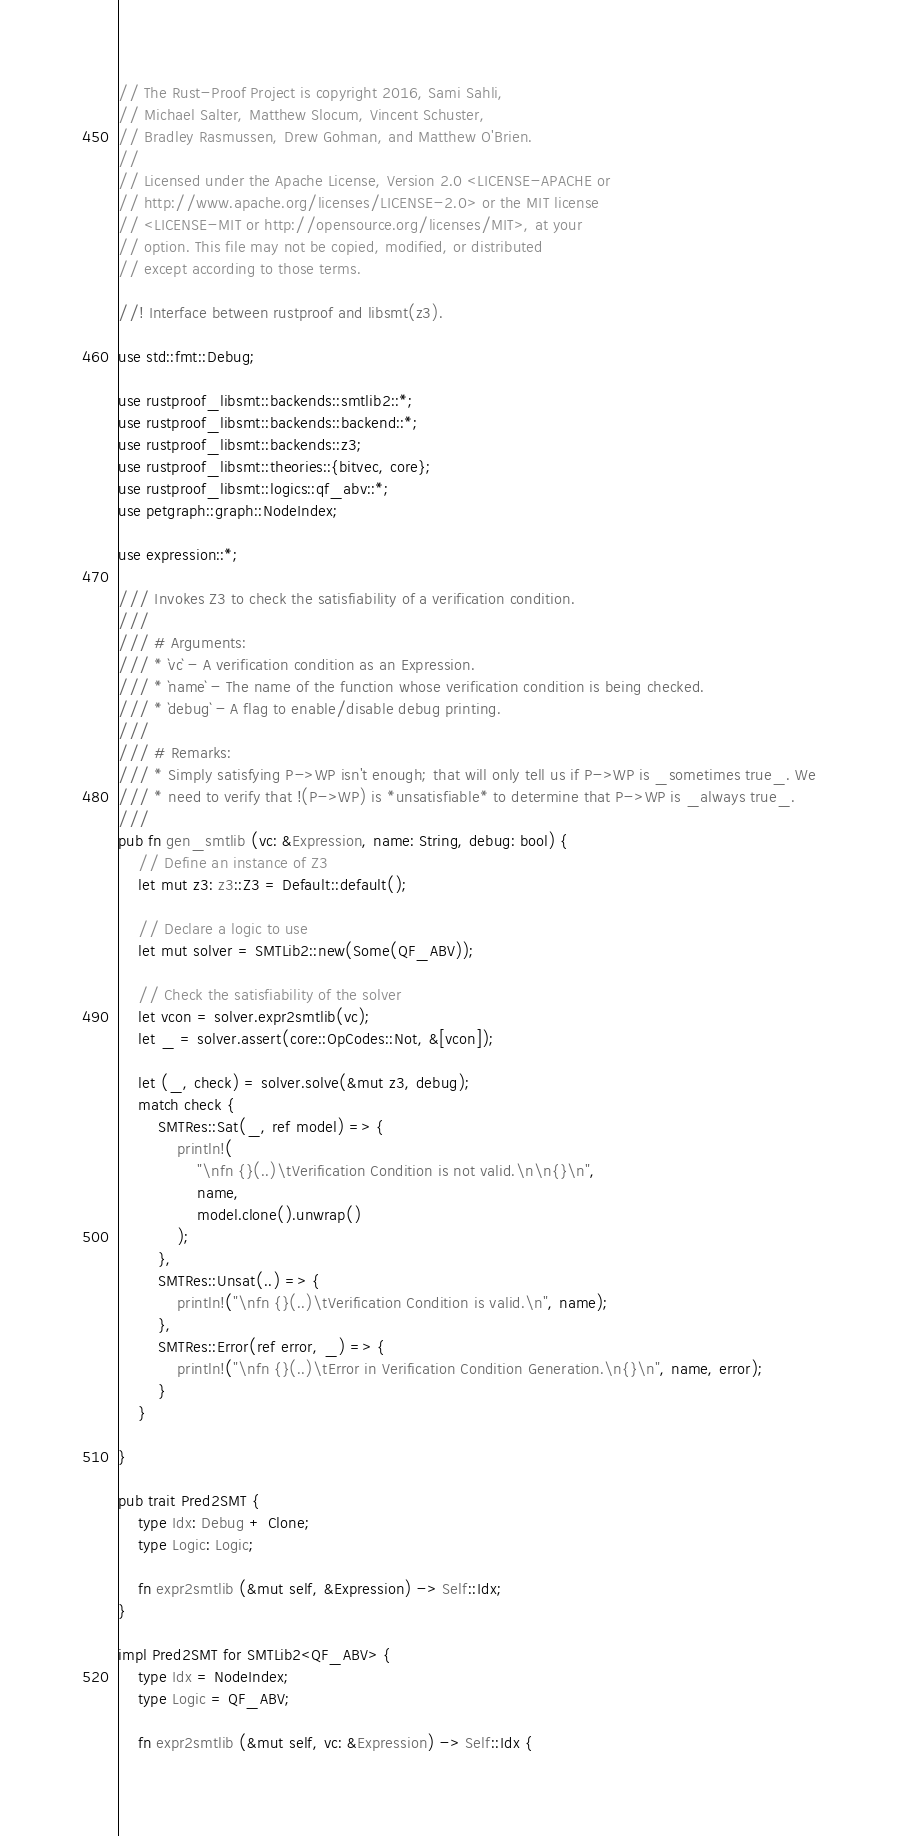Convert code to text. <code><loc_0><loc_0><loc_500><loc_500><_Rust_>// The Rust-Proof Project is copyright 2016, Sami Sahli,
// Michael Salter, Matthew Slocum, Vincent Schuster,
// Bradley Rasmussen, Drew Gohman, and Matthew O'Brien.
//
// Licensed under the Apache License, Version 2.0 <LICENSE-APACHE or
// http://www.apache.org/licenses/LICENSE-2.0> or the MIT license
// <LICENSE-MIT or http://opensource.org/licenses/MIT>, at your
// option. This file may not be copied, modified, or distributed
// except according to those terms.

//! Interface between rustproof and libsmt(z3).

use std::fmt::Debug;

use rustproof_libsmt::backends::smtlib2::*;
use rustproof_libsmt::backends::backend::*;
use rustproof_libsmt::backends::z3;
use rustproof_libsmt::theories::{bitvec, core};
use rustproof_libsmt::logics::qf_abv::*;
use petgraph::graph::NodeIndex;

use expression::*;

/// Invokes Z3 to check the satisfiability of a verification condition.
///
/// # Arguments:
/// * `vc` - A verification condition as an Expression.
/// * `name` - The name of the function whose verification condition is being checked.
/// * `debug` - A flag to enable/disable debug printing.
///
/// # Remarks:
/// * Simply satisfying P->WP isn't enough; that will only tell us if P->WP is _sometimes true_. We
/// * need to verify that !(P->WP) is *unsatisfiable* to determine that P->WP is _always true_.
///
pub fn gen_smtlib (vc: &Expression, name: String, debug: bool) {
    // Define an instance of Z3
    let mut z3: z3::Z3 = Default::default();

    // Declare a logic to use
    let mut solver = SMTLib2::new(Some(QF_ABV));

    // Check the satisfiability of the solver
    let vcon = solver.expr2smtlib(vc);
    let _ = solver.assert(core::OpCodes::Not, &[vcon]);

    let (_, check) = solver.solve(&mut z3, debug);
    match check {
        SMTRes::Sat(_, ref model) => {
            println!(
                "\nfn {}(..)\tVerification Condition is not valid.\n\n{}\n",
                name,
                model.clone().unwrap()
            );
        },
        SMTRes::Unsat(..) => {
            println!("\nfn {}(..)\tVerification Condition is valid.\n", name);
        },
        SMTRes::Error(ref error, _) => {
            println!("\nfn {}(..)\tError in Verification Condition Generation.\n{}\n", name, error);
        }
    }

}

pub trait Pred2SMT {
    type Idx: Debug + Clone;
    type Logic: Logic;

    fn expr2smtlib (&mut self, &Expression) -> Self::Idx;
}

impl Pred2SMT for SMTLib2<QF_ABV> {
    type Idx = NodeIndex;
    type Logic = QF_ABV;

    fn expr2smtlib (&mut self, vc: &Expression) -> Self::Idx {</code> 